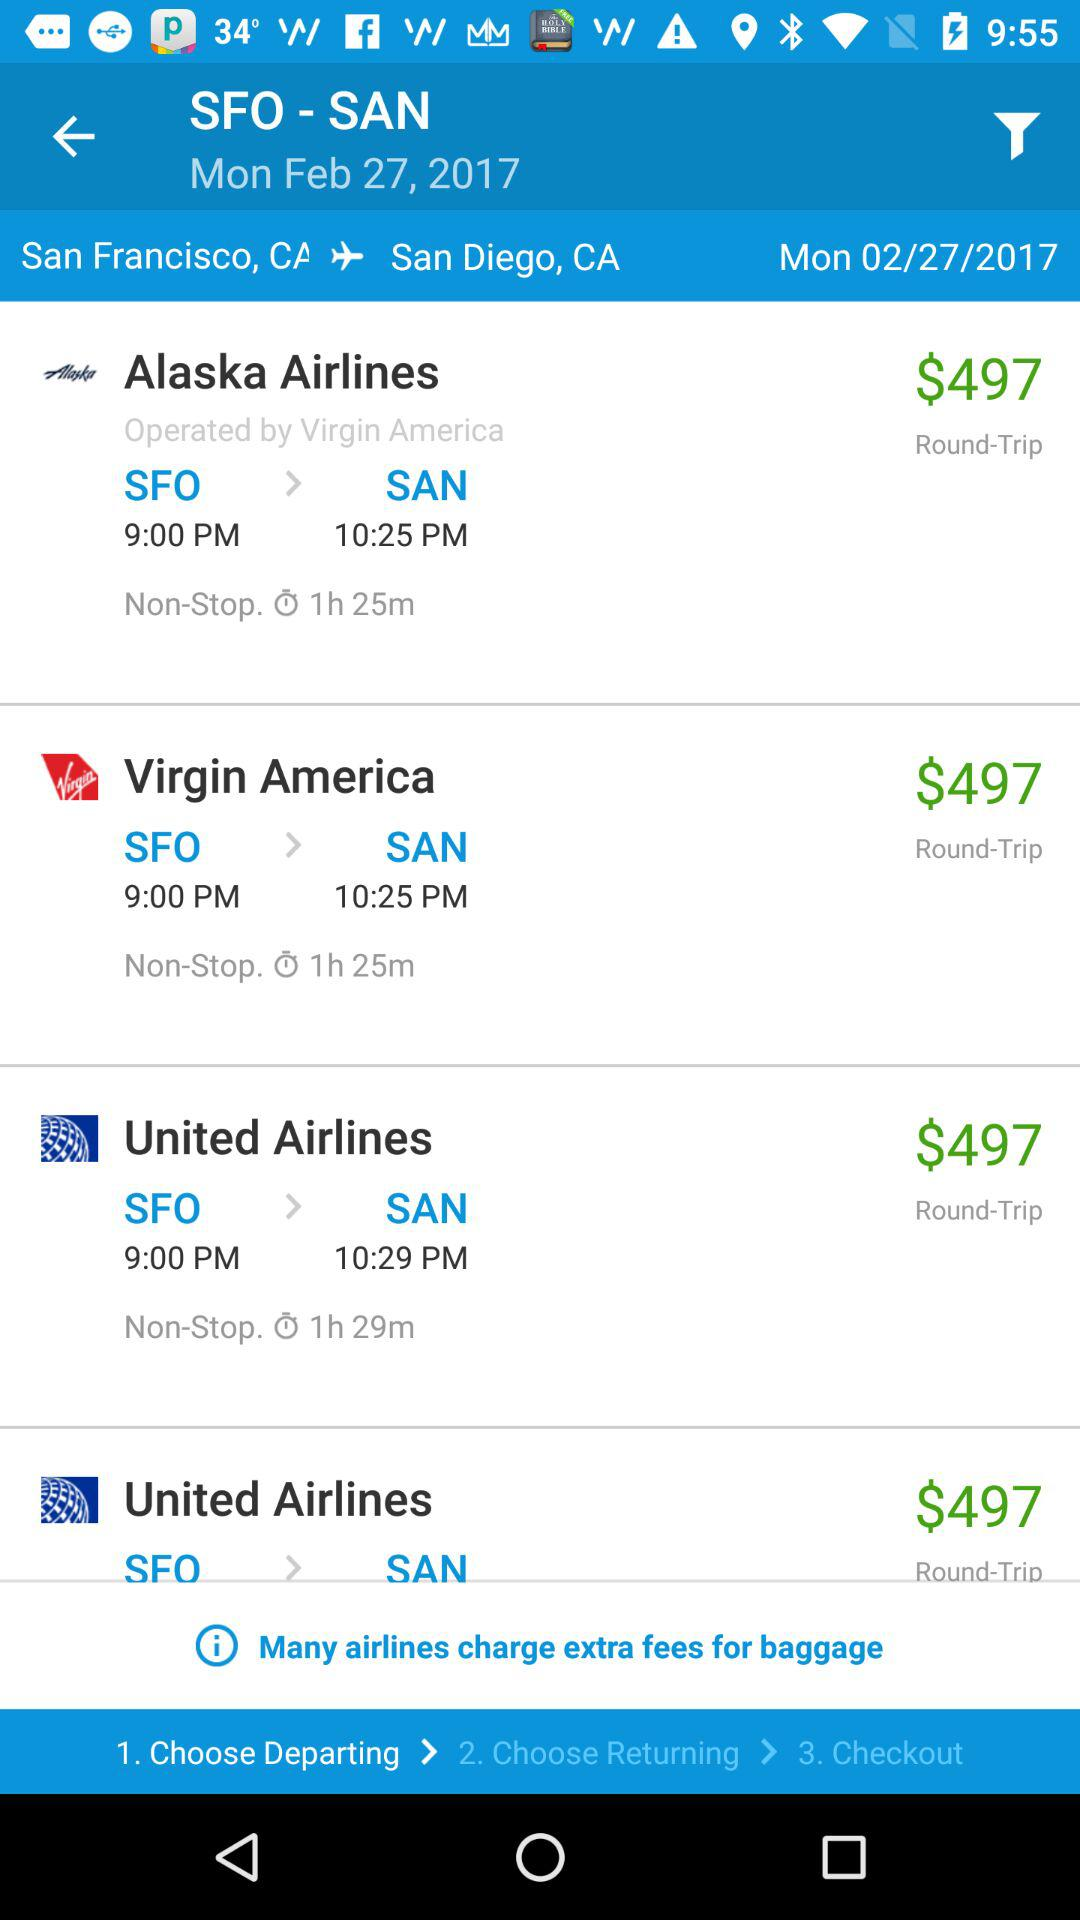Which day falls on February 27, 2017? The day is Monday. 